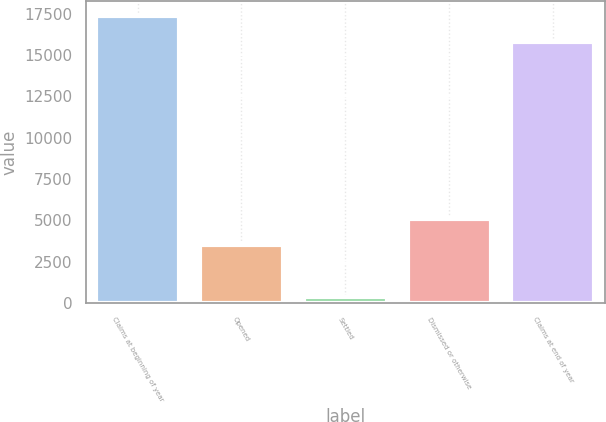<chart> <loc_0><loc_0><loc_500><loc_500><bar_chart><fcel>Claims at beginning of year<fcel>Opened<fcel>Settled<fcel>Dismissed or otherwise<fcel>Claims at end of year<nl><fcel>17385.7<fcel>3501<fcel>379<fcel>5095.7<fcel>15791<nl></chart> 